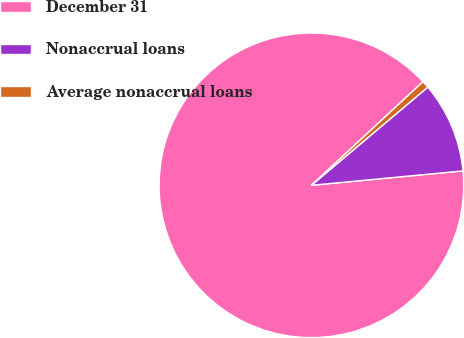Convert chart to OTSL. <chart><loc_0><loc_0><loc_500><loc_500><pie_chart><fcel>December 31<fcel>Nonaccrual loans<fcel>Average nonaccrual loans<nl><fcel>89.6%<fcel>9.64%<fcel>0.76%<nl></chart> 